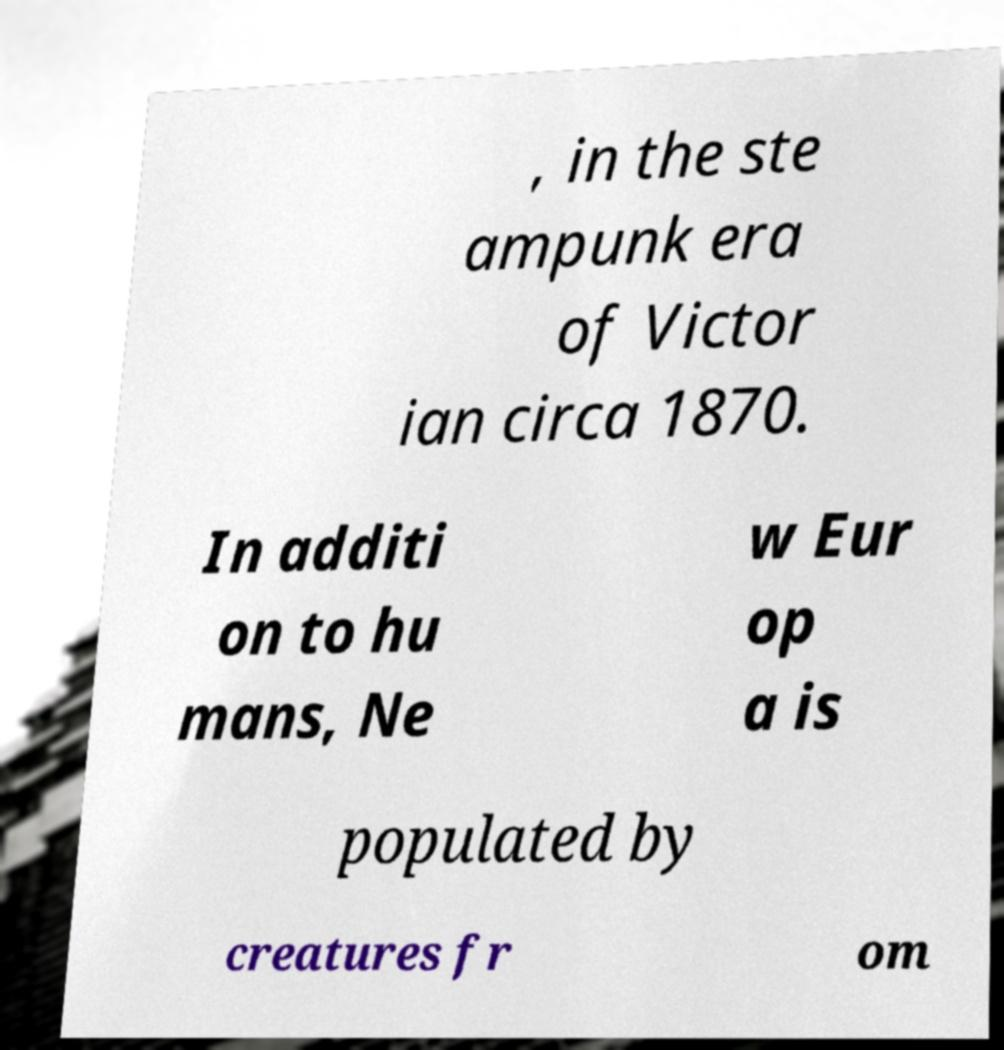Could you extract and type out the text from this image? , in the ste ampunk era of Victor ian circa 1870. In additi on to hu mans, Ne w Eur op a is populated by creatures fr om 